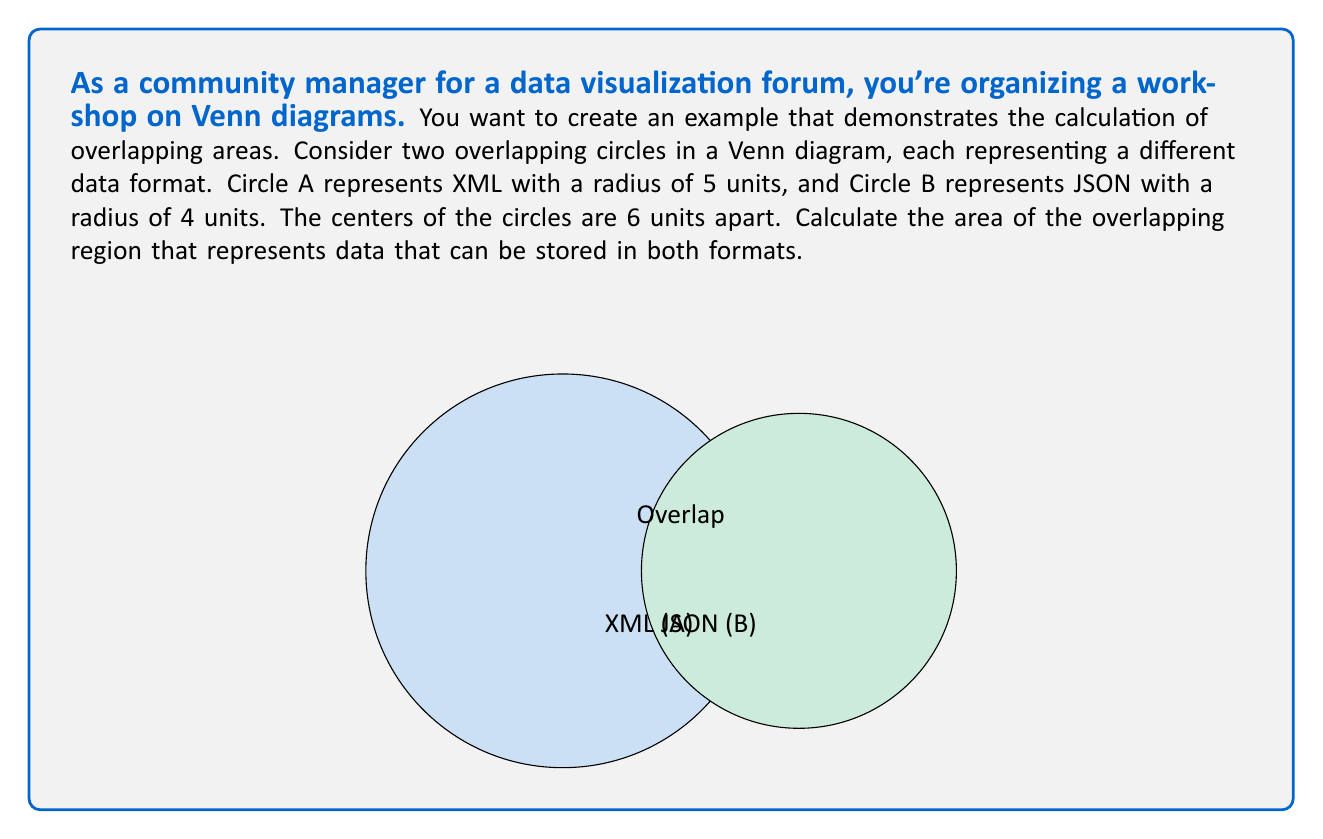Teach me how to tackle this problem. To solve this problem, we'll use the formula for the area of intersection between two circles. Let's break it down step-by-step:

1) First, we need to calculate the distance $d$ between the centers of the circles. We're given that $d = 6$ units.

2) Let $r_1 = 5$ (radius of Circle A) and $r_2 = 4$ (radius of Circle B).

3) The formula for the area of intersection is:

   $$A = r_1^2 \arccos\left(\frac{d^2 + r_1^2 - r_2^2}{2dr_1}\right) + r_2^2 \arccos\left(\frac{d^2 + r_2^2 - r_1^2}{2dr_2}\right) - \frac{1}{2}\sqrt{(-d+r_1+r_2)(d+r_1-r_2)(d-r_1+r_2)(d+r_1+r_2)}$$

4) Let's calculate each part separately:

   Part 1: $r_1^2 \arccos\left(\frac{d^2 + r_1^2 - r_2^2}{2dr_1}\right)$
   
   $= 5^2 \arccos\left(\frac{6^2 + 5^2 - 4^2}{2 \cdot 6 \cdot 5}\right)$
   $= 25 \arccos\left(\frac{61}{60}\right)$

   Part 2: $r_2^2 \arccos\left(\frac{d^2 + r_2^2 - r_1^2}{2dr_2}\right)$
   
   $= 4^2 \arccos\left(\frac{6^2 + 4^2 - 5^2}{2 \cdot 6 \cdot 4}\right)$
   $= 16 \arccos\left(\frac{11}{16}\right)$

   Part 3: $\frac{1}{2}\sqrt{(-d+r_1+r_2)(d+r_1-r_2)(d-r_1+r_2)(d+r_1+r_2)}$
   
   $= \frac{1}{2}\sqrt{(-6+5+4)(6+5-4)(6-5+4)(6+5+4)}$
   $= \frac{1}{2}\sqrt{3 \cdot 7 \cdot 5 \cdot 15}$
   $= \frac{1}{2}\sqrt{1575}$

5) Putting it all together:

   $A = 25 \arccos\left(\frac{61}{60}\right) + 16 \arccos\left(\frac{11}{16}\right) - \frac{1}{2}\sqrt{1575}$

6) Using a calculator or computer to evaluate this expression gives us approximately 12.40 square units.
Answer: The area of the overlapping region is approximately 12.40 square units. 